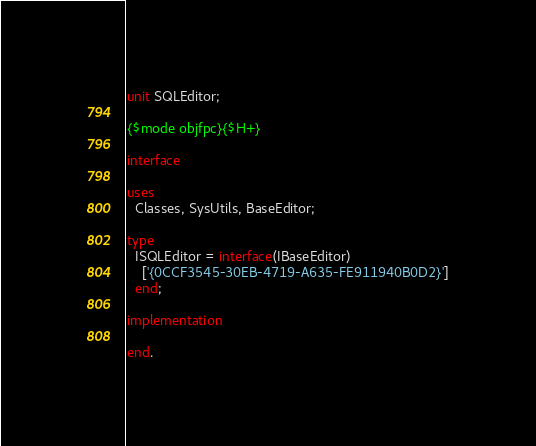Convert code to text. <code><loc_0><loc_0><loc_500><loc_500><_Pascal_>unit SQLEditor;

{$mode objfpc}{$H+}

interface

uses
  Classes, SysUtils, BaseEditor;

type
  ISQLEditor = interface(IBaseEditor)
    ['{0CCF3545-30EB-4719-A635-FE911940B0D2}']
  end;

implementation

end.

</code> 